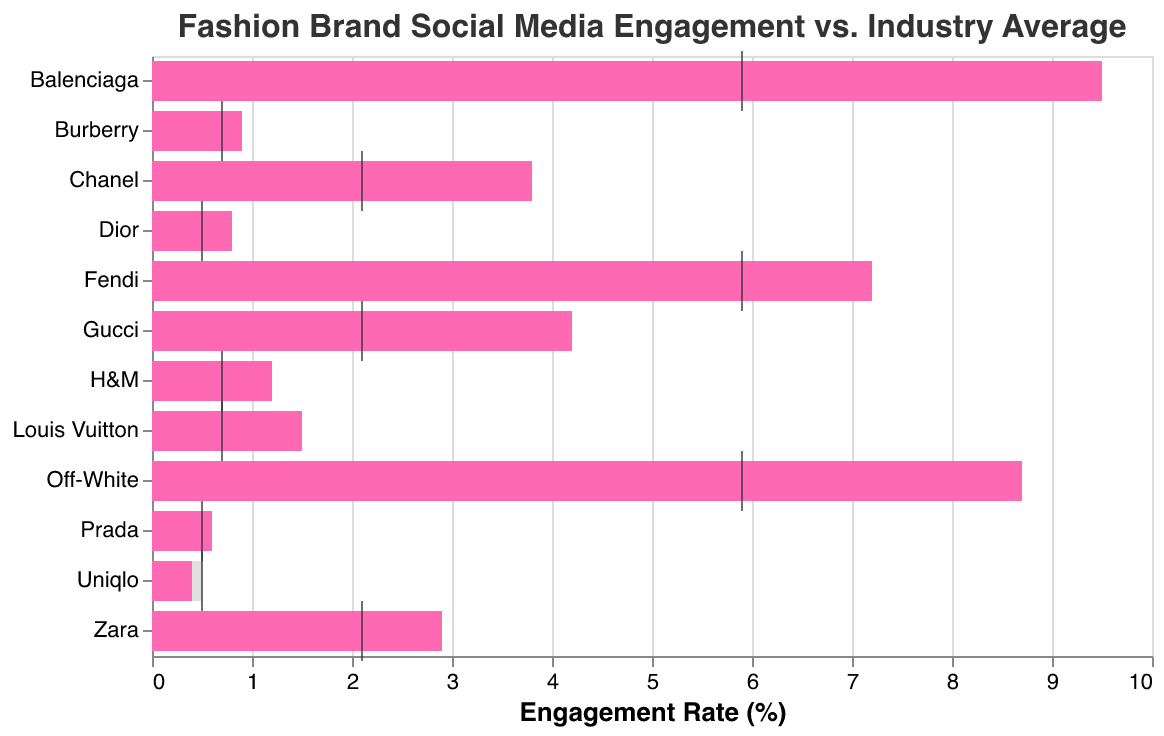What is the title of the figure? The title appears at the top of the figure, which is commonly used to describe the content of the chart.
Answer: Fashion Brand Social Media Engagement vs. Industry Average Which brand has the highest engagement rate on TikTok? Look under the Platform "TikTok" and compare the engagement rates of the brands listed. Identify the highest value.
Answer: Balenciaga How does Gucci's engagement rate on Instagram compare to the industry average on the same platform? Locate Gucci under the Instagram platform, then examine its engagement rate against the industry average.
Answer: Gucci's engagement rate (4.2) is higher than the industry average (2.1) Which brand performs below the industry average on Facebook? Focus on the Facebook platform and compare each brand's engagement rate with the industry average. Identify any brands with lower values.
Answer: Uniqlo What is the engagement rate difference between Louis Vuitton and Burberry on Twitter? Subtract Burberry's engagement rate from Louis Vuitton's engagement rate on the Twitter platform.
Answer: 0.6 On which platform does Chanel have a higher engagement rate than the industry average? Locate Chanel in the chart and observe its engagement rate for each platform. Compare this with the industry averages.
Answer: Instagram How many brands have higher engagement rates than their corresponding industry averages on TikTok? Identify the brands present on TikTok and compare their engagement rates to the industry average. Count the instances where the brand's engagement rate is higher.
Answer: 3 What is the average engagement rate of Zara on Instagram and Burberry on Twitter? Add Zara's engagement rate on Instagram (2.9) and Burberry's rate on Twitter (0.9), then divide by 2.
Answer: 1.9 Which platform has the highest overall engagement rate for fashion brands? Compare the highest engagement rates across different platforms.
Answer: TikTok Is there any brand that has an engagement rate equal to the industry average? Check each brand's engagement rate against the industry average for all platforms, looking for equality.
Answer: No 